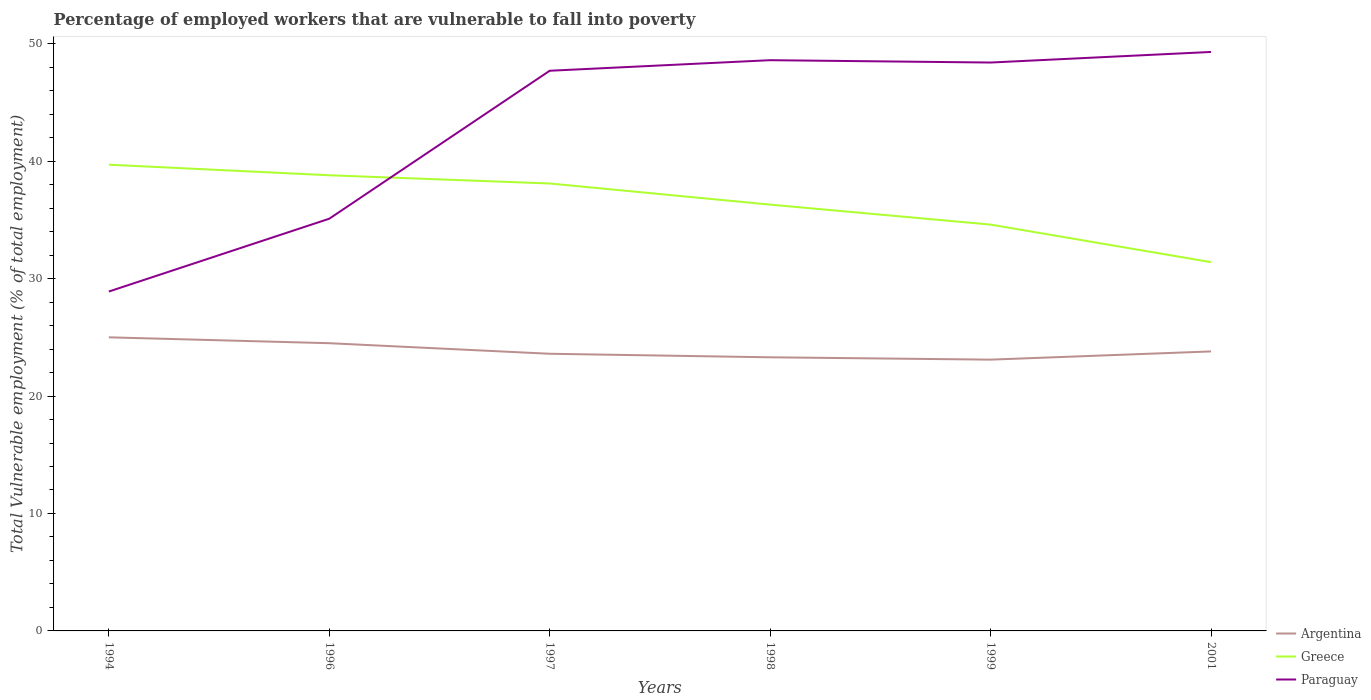Is the number of lines equal to the number of legend labels?
Your answer should be very brief. Yes. Across all years, what is the maximum percentage of employed workers who are vulnerable to fall into poverty in Argentina?
Offer a very short reply. 23.1. What is the total percentage of employed workers who are vulnerable to fall into poverty in Argentina in the graph?
Make the answer very short. 1.7. What is the difference between the highest and the second highest percentage of employed workers who are vulnerable to fall into poverty in Paraguay?
Keep it short and to the point. 20.4. What is the difference between the highest and the lowest percentage of employed workers who are vulnerable to fall into poverty in Paraguay?
Offer a very short reply. 4. How many lines are there?
Make the answer very short. 3. How many years are there in the graph?
Make the answer very short. 6. What is the difference between two consecutive major ticks on the Y-axis?
Your answer should be compact. 10. What is the title of the graph?
Offer a very short reply. Percentage of employed workers that are vulnerable to fall into poverty. What is the label or title of the Y-axis?
Offer a terse response. Total Vulnerable employment (% of total employment). What is the Total Vulnerable employment (% of total employment) in Greece in 1994?
Offer a terse response. 39.7. What is the Total Vulnerable employment (% of total employment) of Paraguay in 1994?
Your answer should be very brief. 28.9. What is the Total Vulnerable employment (% of total employment) of Argentina in 1996?
Offer a very short reply. 24.5. What is the Total Vulnerable employment (% of total employment) in Greece in 1996?
Keep it short and to the point. 38.8. What is the Total Vulnerable employment (% of total employment) in Paraguay in 1996?
Give a very brief answer. 35.1. What is the Total Vulnerable employment (% of total employment) in Argentina in 1997?
Make the answer very short. 23.6. What is the Total Vulnerable employment (% of total employment) of Greece in 1997?
Offer a very short reply. 38.1. What is the Total Vulnerable employment (% of total employment) in Paraguay in 1997?
Ensure brevity in your answer.  47.7. What is the Total Vulnerable employment (% of total employment) of Argentina in 1998?
Your answer should be compact. 23.3. What is the Total Vulnerable employment (% of total employment) of Greece in 1998?
Offer a terse response. 36.3. What is the Total Vulnerable employment (% of total employment) of Paraguay in 1998?
Make the answer very short. 48.6. What is the Total Vulnerable employment (% of total employment) in Argentina in 1999?
Offer a very short reply. 23.1. What is the Total Vulnerable employment (% of total employment) of Greece in 1999?
Keep it short and to the point. 34.6. What is the Total Vulnerable employment (% of total employment) in Paraguay in 1999?
Ensure brevity in your answer.  48.4. What is the Total Vulnerable employment (% of total employment) of Argentina in 2001?
Provide a succinct answer. 23.8. What is the Total Vulnerable employment (% of total employment) in Greece in 2001?
Provide a succinct answer. 31.4. What is the Total Vulnerable employment (% of total employment) of Paraguay in 2001?
Make the answer very short. 49.3. Across all years, what is the maximum Total Vulnerable employment (% of total employment) of Greece?
Your response must be concise. 39.7. Across all years, what is the maximum Total Vulnerable employment (% of total employment) in Paraguay?
Your answer should be compact. 49.3. Across all years, what is the minimum Total Vulnerable employment (% of total employment) in Argentina?
Offer a very short reply. 23.1. Across all years, what is the minimum Total Vulnerable employment (% of total employment) of Greece?
Provide a succinct answer. 31.4. Across all years, what is the minimum Total Vulnerable employment (% of total employment) in Paraguay?
Provide a short and direct response. 28.9. What is the total Total Vulnerable employment (% of total employment) of Argentina in the graph?
Offer a very short reply. 143.3. What is the total Total Vulnerable employment (% of total employment) in Greece in the graph?
Provide a short and direct response. 218.9. What is the total Total Vulnerable employment (% of total employment) in Paraguay in the graph?
Your answer should be very brief. 258. What is the difference between the Total Vulnerable employment (% of total employment) of Greece in 1994 and that in 1996?
Your answer should be very brief. 0.9. What is the difference between the Total Vulnerable employment (% of total employment) in Paraguay in 1994 and that in 1996?
Give a very brief answer. -6.2. What is the difference between the Total Vulnerable employment (% of total employment) in Argentina in 1994 and that in 1997?
Offer a terse response. 1.4. What is the difference between the Total Vulnerable employment (% of total employment) in Greece in 1994 and that in 1997?
Make the answer very short. 1.6. What is the difference between the Total Vulnerable employment (% of total employment) in Paraguay in 1994 and that in 1997?
Keep it short and to the point. -18.8. What is the difference between the Total Vulnerable employment (% of total employment) in Argentina in 1994 and that in 1998?
Ensure brevity in your answer.  1.7. What is the difference between the Total Vulnerable employment (% of total employment) in Paraguay in 1994 and that in 1998?
Offer a terse response. -19.7. What is the difference between the Total Vulnerable employment (% of total employment) in Greece in 1994 and that in 1999?
Keep it short and to the point. 5.1. What is the difference between the Total Vulnerable employment (% of total employment) in Paraguay in 1994 and that in 1999?
Offer a terse response. -19.5. What is the difference between the Total Vulnerable employment (% of total employment) of Argentina in 1994 and that in 2001?
Provide a short and direct response. 1.2. What is the difference between the Total Vulnerable employment (% of total employment) in Greece in 1994 and that in 2001?
Your answer should be very brief. 8.3. What is the difference between the Total Vulnerable employment (% of total employment) of Paraguay in 1994 and that in 2001?
Offer a terse response. -20.4. What is the difference between the Total Vulnerable employment (% of total employment) of Argentina in 1996 and that in 1997?
Provide a succinct answer. 0.9. What is the difference between the Total Vulnerable employment (% of total employment) in Paraguay in 1996 and that in 1997?
Make the answer very short. -12.6. What is the difference between the Total Vulnerable employment (% of total employment) of Argentina in 1996 and that in 1998?
Make the answer very short. 1.2. What is the difference between the Total Vulnerable employment (% of total employment) of Greece in 1996 and that in 1998?
Offer a very short reply. 2.5. What is the difference between the Total Vulnerable employment (% of total employment) of Greece in 1996 and that in 1999?
Provide a short and direct response. 4.2. What is the difference between the Total Vulnerable employment (% of total employment) of Paraguay in 1997 and that in 1998?
Keep it short and to the point. -0.9. What is the difference between the Total Vulnerable employment (% of total employment) of Argentina in 1997 and that in 1999?
Give a very brief answer. 0.5. What is the difference between the Total Vulnerable employment (% of total employment) of Greece in 1997 and that in 1999?
Your answer should be compact. 3.5. What is the difference between the Total Vulnerable employment (% of total employment) of Paraguay in 1997 and that in 1999?
Give a very brief answer. -0.7. What is the difference between the Total Vulnerable employment (% of total employment) in Greece in 1997 and that in 2001?
Ensure brevity in your answer.  6.7. What is the difference between the Total Vulnerable employment (% of total employment) in Paraguay in 1997 and that in 2001?
Your response must be concise. -1.6. What is the difference between the Total Vulnerable employment (% of total employment) in Greece in 1998 and that in 1999?
Your response must be concise. 1.7. What is the difference between the Total Vulnerable employment (% of total employment) in Argentina in 1998 and that in 2001?
Keep it short and to the point. -0.5. What is the difference between the Total Vulnerable employment (% of total employment) in Greece in 1998 and that in 2001?
Keep it short and to the point. 4.9. What is the difference between the Total Vulnerable employment (% of total employment) in Argentina in 1999 and that in 2001?
Your response must be concise. -0.7. What is the difference between the Total Vulnerable employment (% of total employment) in Greece in 1994 and the Total Vulnerable employment (% of total employment) in Paraguay in 1996?
Your response must be concise. 4.6. What is the difference between the Total Vulnerable employment (% of total employment) of Argentina in 1994 and the Total Vulnerable employment (% of total employment) of Paraguay in 1997?
Your response must be concise. -22.7. What is the difference between the Total Vulnerable employment (% of total employment) in Argentina in 1994 and the Total Vulnerable employment (% of total employment) in Paraguay in 1998?
Your answer should be compact. -23.6. What is the difference between the Total Vulnerable employment (% of total employment) of Argentina in 1994 and the Total Vulnerable employment (% of total employment) of Paraguay in 1999?
Your response must be concise. -23.4. What is the difference between the Total Vulnerable employment (% of total employment) of Argentina in 1994 and the Total Vulnerable employment (% of total employment) of Greece in 2001?
Make the answer very short. -6.4. What is the difference between the Total Vulnerable employment (% of total employment) in Argentina in 1994 and the Total Vulnerable employment (% of total employment) in Paraguay in 2001?
Your answer should be very brief. -24.3. What is the difference between the Total Vulnerable employment (% of total employment) of Greece in 1994 and the Total Vulnerable employment (% of total employment) of Paraguay in 2001?
Provide a succinct answer. -9.6. What is the difference between the Total Vulnerable employment (% of total employment) of Argentina in 1996 and the Total Vulnerable employment (% of total employment) of Greece in 1997?
Make the answer very short. -13.6. What is the difference between the Total Vulnerable employment (% of total employment) of Argentina in 1996 and the Total Vulnerable employment (% of total employment) of Paraguay in 1997?
Provide a succinct answer. -23.2. What is the difference between the Total Vulnerable employment (% of total employment) in Argentina in 1996 and the Total Vulnerable employment (% of total employment) in Paraguay in 1998?
Offer a very short reply. -24.1. What is the difference between the Total Vulnerable employment (% of total employment) in Greece in 1996 and the Total Vulnerable employment (% of total employment) in Paraguay in 1998?
Make the answer very short. -9.8. What is the difference between the Total Vulnerable employment (% of total employment) of Argentina in 1996 and the Total Vulnerable employment (% of total employment) of Greece in 1999?
Offer a very short reply. -10.1. What is the difference between the Total Vulnerable employment (% of total employment) of Argentina in 1996 and the Total Vulnerable employment (% of total employment) of Paraguay in 1999?
Provide a succinct answer. -23.9. What is the difference between the Total Vulnerable employment (% of total employment) in Argentina in 1996 and the Total Vulnerable employment (% of total employment) in Paraguay in 2001?
Offer a very short reply. -24.8. What is the difference between the Total Vulnerable employment (% of total employment) in Argentina in 1997 and the Total Vulnerable employment (% of total employment) in Greece in 1998?
Give a very brief answer. -12.7. What is the difference between the Total Vulnerable employment (% of total employment) of Argentina in 1997 and the Total Vulnerable employment (% of total employment) of Paraguay in 1999?
Ensure brevity in your answer.  -24.8. What is the difference between the Total Vulnerable employment (% of total employment) of Argentina in 1997 and the Total Vulnerable employment (% of total employment) of Greece in 2001?
Your response must be concise. -7.8. What is the difference between the Total Vulnerable employment (% of total employment) in Argentina in 1997 and the Total Vulnerable employment (% of total employment) in Paraguay in 2001?
Provide a short and direct response. -25.7. What is the difference between the Total Vulnerable employment (% of total employment) in Argentina in 1998 and the Total Vulnerable employment (% of total employment) in Greece in 1999?
Offer a terse response. -11.3. What is the difference between the Total Vulnerable employment (% of total employment) in Argentina in 1998 and the Total Vulnerable employment (% of total employment) in Paraguay in 1999?
Keep it short and to the point. -25.1. What is the difference between the Total Vulnerable employment (% of total employment) of Greece in 1998 and the Total Vulnerable employment (% of total employment) of Paraguay in 1999?
Provide a succinct answer. -12.1. What is the difference between the Total Vulnerable employment (% of total employment) in Argentina in 1998 and the Total Vulnerable employment (% of total employment) in Greece in 2001?
Your answer should be compact. -8.1. What is the difference between the Total Vulnerable employment (% of total employment) in Argentina in 1998 and the Total Vulnerable employment (% of total employment) in Paraguay in 2001?
Provide a short and direct response. -26. What is the difference between the Total Vulnerable employment (% of total employment) of Argentina in 1999 and the Total Vulnerable employment (% of total employment) of Greece in 2001?
Give a very brief answer. -8.3. What is the difference between the Total Vulnerable employment (% of total employment) of Argentina in 1999 and the Total Vulnerable employment (% of total employment) of Paraguay in 2001?
Keep it short and to the point. -26.2. What is the difference between the Total Vulnerable employment (% of total employment) in Greece in 1999 and the Total Vulnerable employment (% of total employment) in Paraguay in 2001?
Offer a very short reply. -14.7. What is the average Total Vulnerable employment (% of total employment) in Argentina per year?
Offer a terse response. 23.88. What is the average Total Vulnerable employment (% of total employment) of Greece per year?
Give a very brief answer. 36.48. In the year 1994, what is the difference between the Total Vulnerable employment (% of total employment) in Argentina and Total Vulnerable employment (% of total employment) in Greece?
Your answer should be very brief. -14.7. In the year 1994, what is the difference between the Total Vulnerable employment (% of total employment) in Argentina and Total Vulnerable employment (% of total employment) in Paraguay?
Provide a short and direct response. -3.9. In the year 1994, what is the difference between the Total Vulnerable employment (% of total employment) of Greece and Total Vulnerable employment (% of total employment) of Paraguay?
Offer a very short reply. 10.8. In the year 1996, what is the difference between the Total Vulnerable employment (% of total employment) of Argentina and Total Vulnerable employment (% of total employment) of Greece?
Give a very brief answer. -14.3. In the year 1997, what is the difference between the Total Vulnerable employment (% of total employment) of Argentina and Total Vulnerable employment (% of total employment) of Paraguay?
Provide a short and direct response. -24.1. In the year 1997, what is the difference between the Total Vulnerable employment (% of total employment) of Greece and Total Vulnerable employment (% of total employment) of Paraguay?
Your answer should be compact. -9.6. In the year 1998, what is the difference between the Total Vulnerable employment (% of total employment) of Argentina and Total Vulnerable employment (% of total employment) of Paraguay?
Ensure brevity in your answer.  -25.3. In the year 1998, what is the difference between the Total Vulnerable employment (% of total employment) in Greece and Total Vulnerable employment (% of total employment) in Paraguay?
Give a very brief answer. -12.3. In the year 1999, what is the difference between the Total Vulnerable employment (% of total employment) in Argentina and Total Vulnerable employment (% of total employment) in Paraguay?
Provide a succinct answer. -25.3. In the year 2001, what is the difference between the Total Vulnerable employment (% of total employment) of Argentina and Total Vulnerable employment (% of total employment) of Paraguay?
Your answer should be compact. -25.5. In the year 2001, what is the difference between the Total Vulnerable employment (% of total employment) in Greece and Total Vulnerable employment (% of total employment) in Paraguay?
Offer a terse response. -17.9. What is the ratio of the Total Vulnerable employment (% of total employment) of Argentina in 1994 to that in 1996?
Provide a short and direct response. 1.02. What is the ratio of the Total Vulnerable employment (% of total employment) of Greece in 1994 to that in 1996?
Your response must be concise. 1.02. What is the ratio of the Total Vulnerable employment (% of total employment) in Paraguay in 1994 to that in 1996?
Your response must be concise. 0.82. What is the ratio of the Total Vulnerable employment (% of total employment) of Argentina in 1994 to that in 1997?
Provide a succinct answer. 1.06. What is the ratio of the Total Vulnerable employment (% of total employment) in Greece in 1994 to that in 1997?
Your response must be concise. 1.04. What is the ratio of the Total Vulnerable employment (% of total employment) of Paraguay in 1994 to that in 1997?
Provide a succinct answer. 0.61. What is the ratio of the Total Vulnerable employment (% of total employment) in Argentina in 1994 to that in 1998?
Offer a very short reply. 1.07. What is the ratio of the Total Vulnerable employment (% of total employment) of Greece in 1994 to that in 1998?
Give a very brief answer. 1.09. What is the ratio of the Total Vulnerable employment (% of total employment) in Paraguay in 1994 to that in 1998?
Offer a terse response. 0.59. What is the ratio of the Total Vulnerable employment (% of total employment) in Argentina in 1994 to that in 1999?
Provide a short and direct response. 1.08. What is the ratio of the Total Vulnerable employment (% of total employment) in Greece in 1994 to that in 1999?
Your answer should be very brief. 1.15. What is the ratio of the Total Vulnerable employment (% of total employment) in Paraguay in 1994 to that in 1999?
Provide a succinct answer. 0.6. What is the ratio of the Total Vulnerable employment (% of total employment) in Argentina in 1994 to that in 2001?
Provide a succinct answer. 1.05. What is the ratio of the Total Vulnerable employment (% of total employment) in Greece in 1994 to that in 2001?
Your answer should be compact. 1.26. What is the ratio of the Total Vulnerable employment (% of total employment) in Paraguay in 1994 to that in 2001?
Keep it short and to the point. 0.59. What is the ratio of the Total Vulnerable employment (% of total employment) in Argentina in 1996 to that in 1997?
Give a very brief answer. 1.04. What is the ratio of the Total Vulnerable employment (% of total employment) in Greece in 1996 to that in 1997?
Ensure brevity in your answer.  1.02. What is the ratio of the Total Vulnerable employment (% of total employment) of Paraguay in 1996 to that in 1997?
Keep it short and to the point. 0.74. What is the ratio of the Total Vulnerable employment (% of total employment) of Argentina in 1996 to that in 1998?
Your response must be concise. 1.05. What is the ratio of the Total Vulnerable employment (% of total employment) of Greece in 1996 to that in 1998?
Give a very brief answer. 1.07. What is the ratio of the Total Vulnerable employment (% of total employment) in Paraguay in 1996 to that in 1998?
Your answer should be compact. 0.72. What is the ratio of the Total Vulnerable employment (% of total employment) in Argentina in 1996 to that in 1999?
Offer a very short reply. 1.06. What is the ratio of the Total Vulnerable employment (% of total employment) in Greece in 1996 to that in 1999?
Keep it short and to the point. 1.12. What is the ratio of the Total Vulnerable employment (% of total employment) of Paraguay in 1996 to that in 1999?
Keep it short and to the point. 0.73. What is the ratio of the Total Vulnerable employment (% of total employment) in Argentina in 1996 to that in 2001?
Your answer should be compact. 1.03. What is the ratio of the Total Vulnerable employment (% of total employment) of Greece in 1996 to that in 2001?
Make the answer very short. 1.24. What is the ratio of the Total Vulnerable employment (% of total employment) of Paraguay in 1996 to that in 2001?
Ensure brevity in your answer.  0.71. What is the ratio of the Total Vulnerable employment (% of total employment) in Argentina in 1997 to that in 1998?
Your answer should be very brief. 1.01. What is the ratio of the Total Vulnerable employment (% of total employment) in Greece in 1997 to that in 1998?
Provide a succinct answer. 1.05. What is the ratio of the Total Vulnerable employment (% of total employment) of Paraguay in 1997 to that in 1998?
Your answer should be compact. 0.98. What is the ratio of the Total Vulnerable employment (% of total employment) in Argentina in 1997 to that in 1999?
Provide a succinct answer. 1.02. What is the ratio of the Total Vulnerable employment (% of total employment) in Greece in 1997 to that in 1999?
Provide a succinct answer. 1.1. What is the ratio of the Total Vulnerable employment (% of total employment) in Paraguay in 1997 to that in 1999?
Give a very brief answer. 0.99. What is the ratio of the Total Vulnerable employment (% of total employment) in Argentina in 1997 to that in 2001?
Provide a succinct answer. 0.99. What is the ratio of the Total Vulnerable employment (% of total employment) in Greece in 1997 to that in 2001?
Give a very brief answer. 1.21. What is the ratio of the Total Vulnerable employment (% of total employment) in Paraguay in 1997 to that in 2001?
Ensure brevity in your answer.  0.97. What is the ratio of the Total Vulnerable employment (% of total employment) in Argentina in 1998 to that in 1999?
Provide a succinct answer. 1.01. What is the ratio of the Total Vulnerable employment (% of total employment) in Greece in 1998 to that in 1999?
Keep it short and to the point. 1.05. What is the ratio of the Total Vulnerable employment (% of total employment) in Greece in 1998 to that in 2001?
Provide a short and direct response. 1.16. What is the ratio of the Total Vulnerable employment (% of total employment) of Paraguay in 1998 to that in 2001?
Offer a terse response. 0.99. What is the ratio of the Total Vulnerable employment (% of total employment) in Argentina in 1999 to that in 2001?
Keep it short and to the point. 0.97. What is the ratio of the Total Vulnerable employment (% of total employment) in Greece in 1999 to that in 2001?
Your answer should be very brief. 1.1. What is the ratio of the Total Vulnerable employment (% of total employment) in Paraguay in 1999 to that in 2001?
Make the answer very short. 0.98. What is the difference between the highest and the second highest Total Vulnerable employment (% of total employment) in Greece?
Your answer should be compact. 0.9. What is the difference between the highest and the lowest Total Vulnerable employment (% of total employment) of Argentina?
Provide a short and direct response. 1.9. What is the difference between the highest and the lowest Total Vulnerable employment (% of total employment) of Paraguay?
Give a very brief answer. 20.4. 